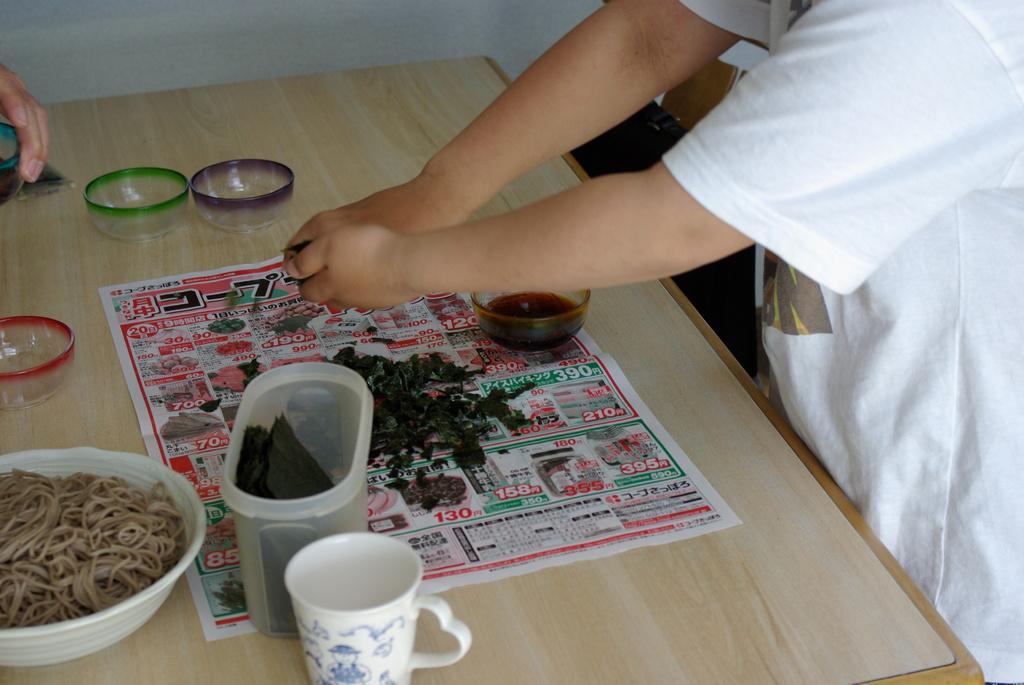Please provide a concise description of this image. In this picture we can observe a table on which there is a paper, cup, bowl and some grass bowls. In front of the table there is a person standing, wearing a white color t-shirt. In the background there is a wall. 